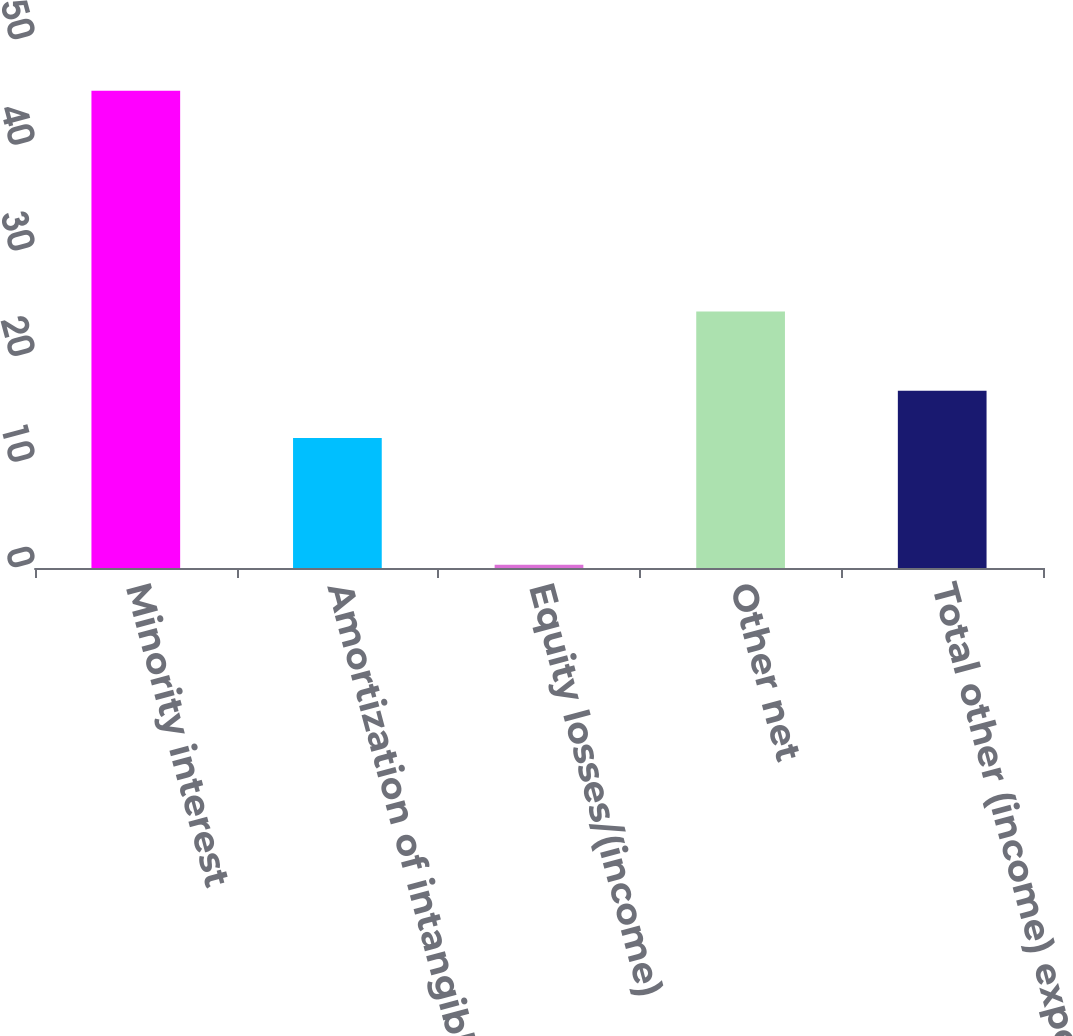Convert chart. <chart><loc_0><loc_0><loc_500><loc_500><bar_chart><fcel>Minority interest<fcel>Amortization of intangible<fcel>Equity losses/(income)<fcel>Other net<fcel>Total other (income) expense<nl><fcel>45.2<fcel>12.3<fcel>0.3<fcel>24.3<fcel>16.79<nl></chart> 